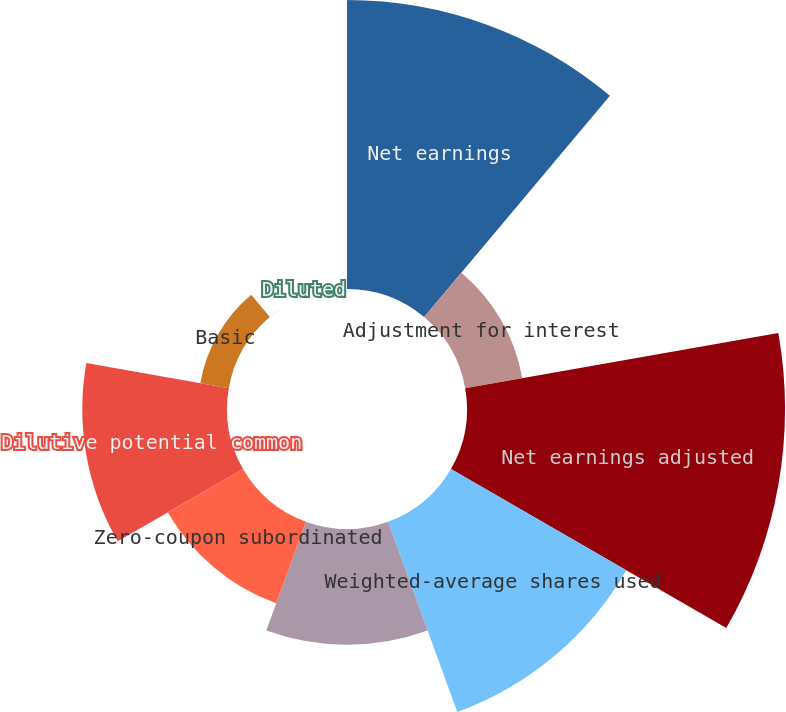Convert chart. <chart><loc_0><loc_0><loc_500><loc_500><pie_chart><fcel>Net earnings<fcel>Adjustment for interest<fcel>Net earnings adjusted<fcel>Weighted-average shares used<fcel>Dilution from employee stock<fcel>Zero-coupon subordinated<fcel>Dilutive potential common<fcel>Basic<fcel>Diluted<nl><fcel>23.23%<fcel>4.66%<fcel>25.56%<fcel>16.28%<fcel>9.31%<fcel>6.98%<fcel>11.63%<fcel>2.33%<fcel>0.01%<nl></chart> 